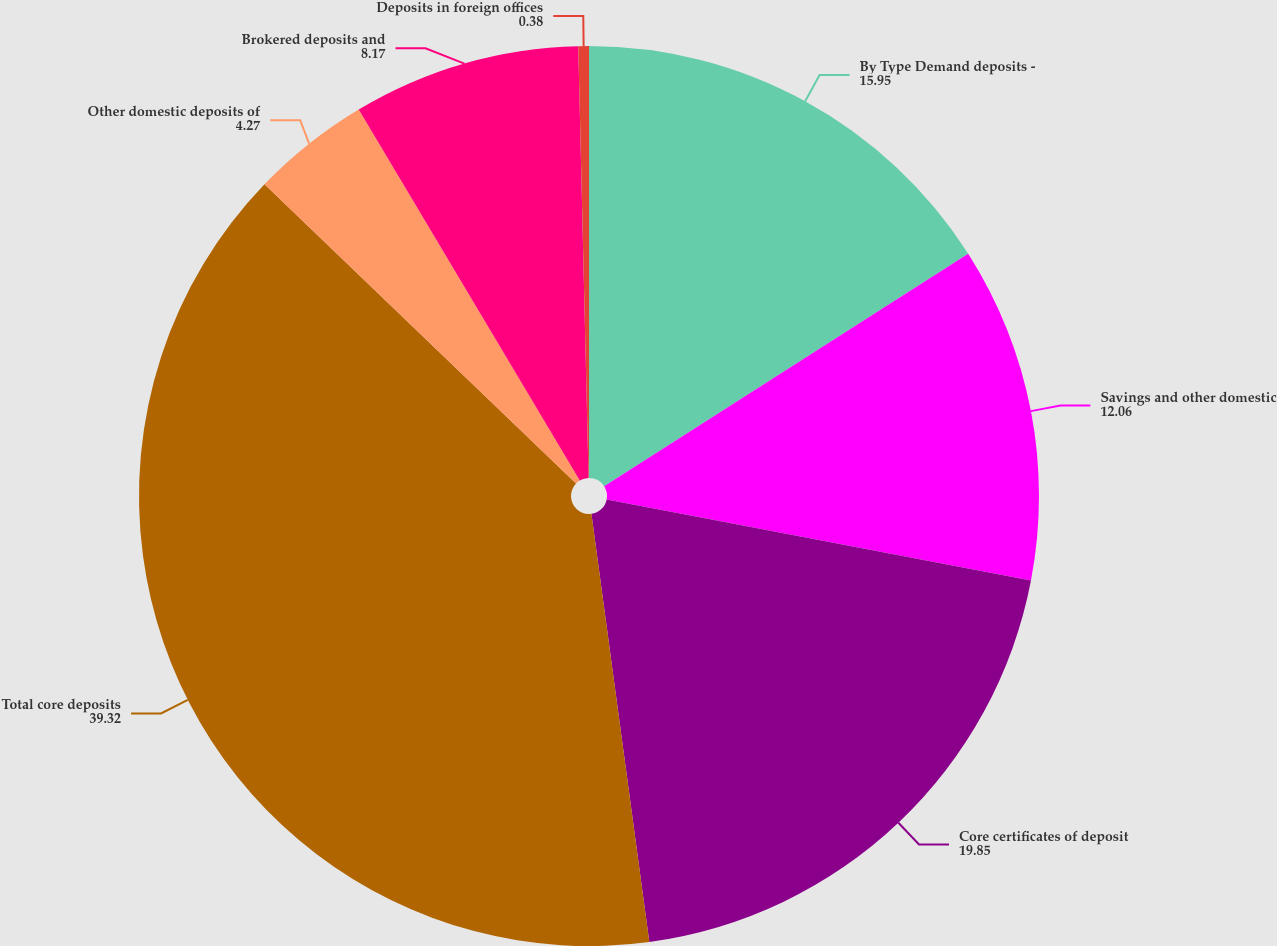Convert chart. <chart><loc_0><loc_0><loc_500><loc_500><pie_chart><fcel>By Type Demand deposits -<fcel>Savings and other domestic<fcel>Core certificates of deposit<fcel>Total core deposits<fcel>Other domestic deposits of<fcel>Brokered deposits and<fcel>Deposits in foreign offices<nl><fcel>15.95%<fcel>12.06%<fcel>19.85%<fcel>39.32%<fcel>4.27%<fcel>8.17%<fcel>0.38%<nl></chart> 